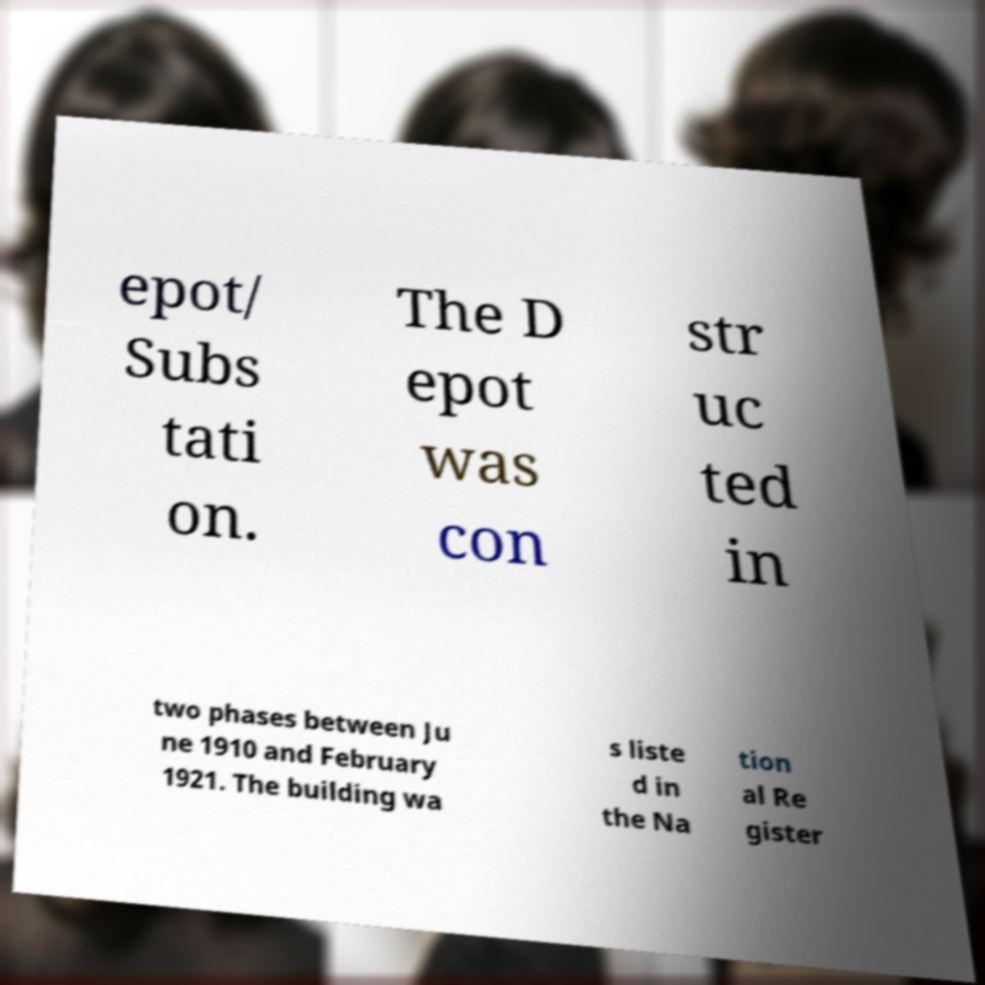Please read and relay the text visible in this image. What does it say? epot/ Subs tati on. The D epot was con str uc ted in two phases between Ju ne 1910 and February 1921. The building wa s liste d in the Na tion al Re gister 